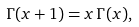<formula> <loc_0><loc_0><loc_500><loc_500>\Gamma ( x + 1 ) = x \, \Gamma ( x ) ,</formula> 